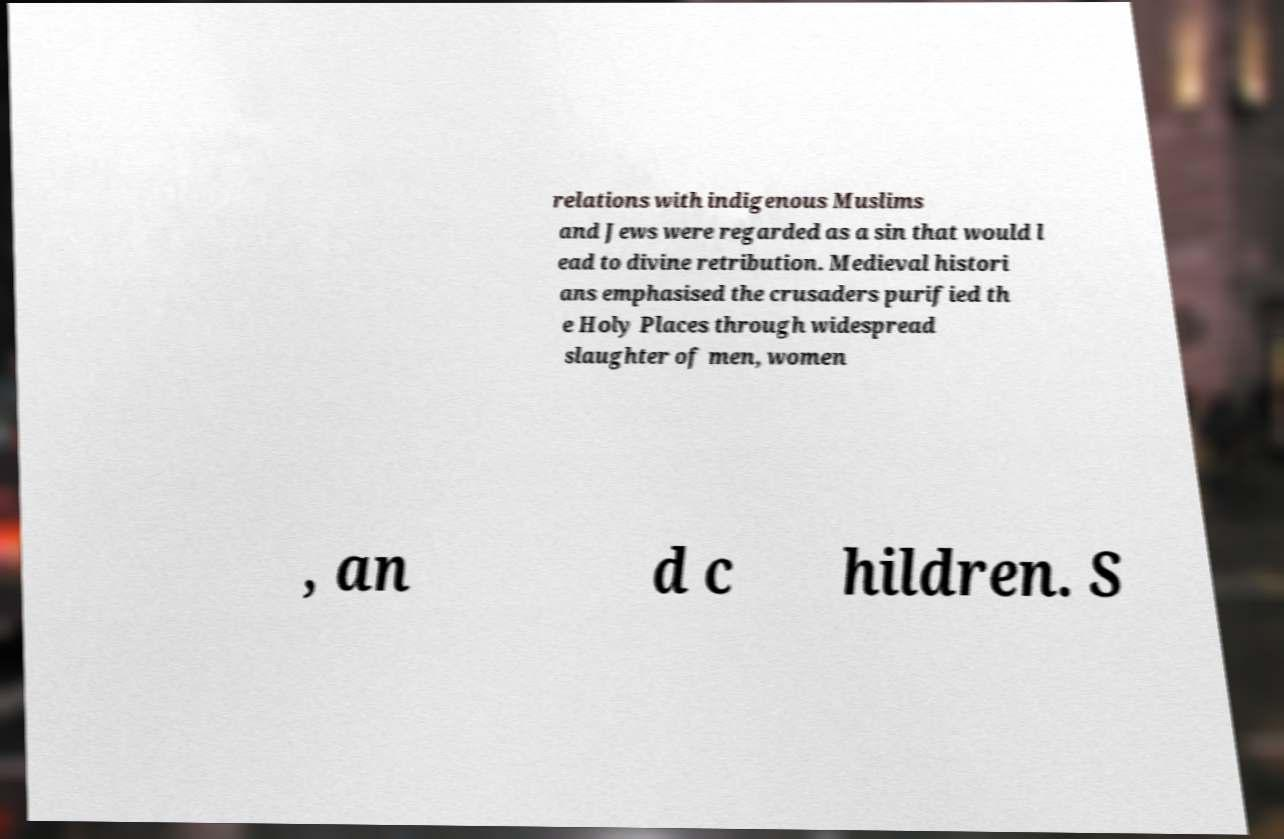I need the written content from this picture converted into text. Can you do that? relations with indigenous Muslims and Jews were regarded as a sin that would l ead to divine retribution. Medieval histori ans emphasised the crusaders purified th e Holy Places through widespread slaughter of men, women , an d c hildren. S 